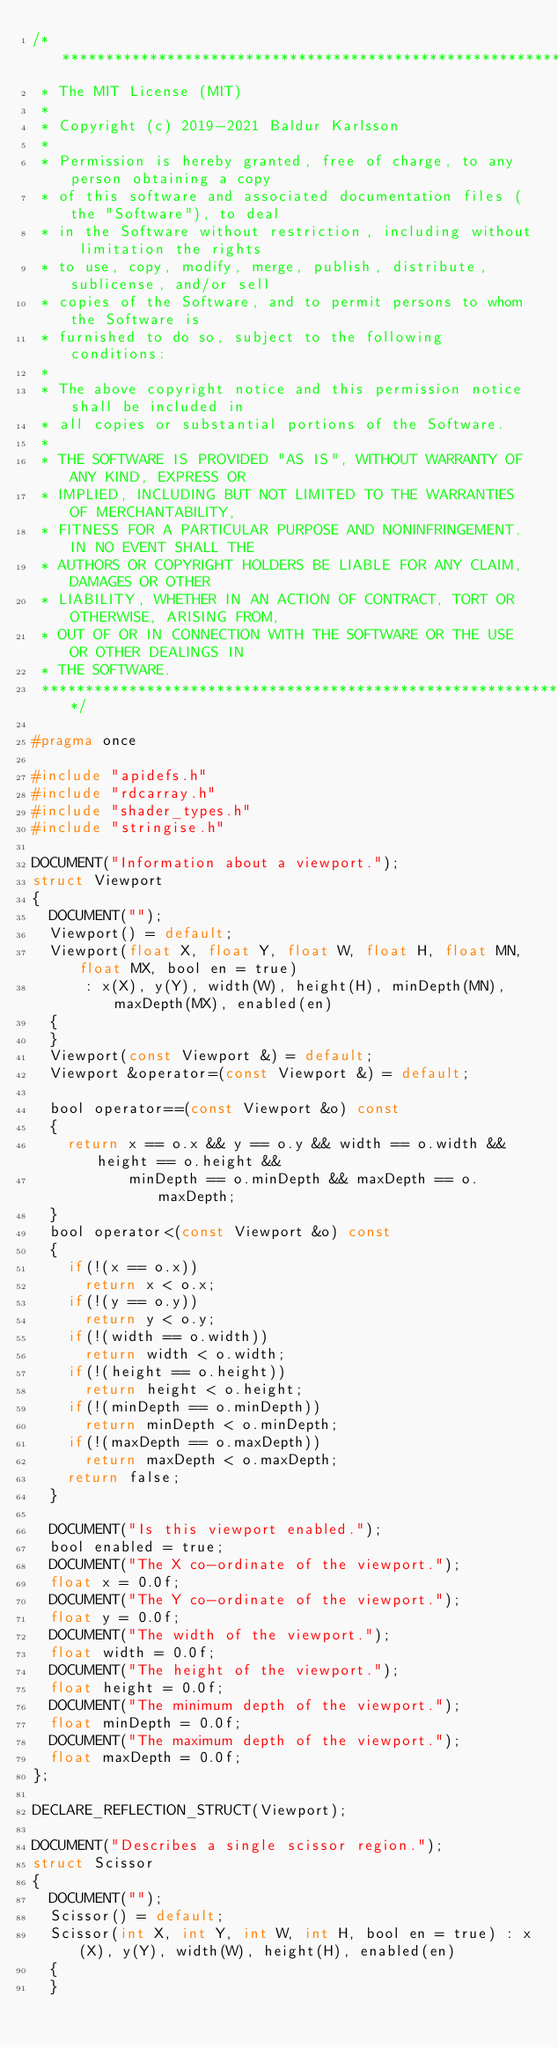Convert code to text. <code><loc_0><loc_0><loc_500><loc_500><_C_>/******************************************************************************
 * The MIT License (MIT)
 *
 * Copyright (c) 2019-2021 Baldur Karlsson
 *
 * Permission is hereby granted, free of charge, to any person obtaining a copy
 * of this software and associated documentation files (the "Software"), to deal
 * in the Software without restriction, including without limitation the rights
 * to use, copy, modify, merge, publish, distribute, sublicense, and/or sell
 * copies of the Software, and to permit persons to whom the Software is
 * furnished to do so, subject to the following conditions:
 *
 * The above copyright notice and this permission notice shall be included in
 * all copies or substantial portions of the Software.
 *
 * THE SOFTWARE IS PROVIDED "AS IS", WITHOUT WARRANTY OF ANY KIND, EXPRESS OR
 * IMPLIED, INCLUDING BUT NOT LIMITED TO THE WARRANTIES OF MERCHANTABILITY,
 * FITNESS FOR A PARTICULAR PURPOSE AND NONINFRINGEMENT. IN NO EVENT SHALL THE
 * AUTHORS OR COPYRIGHT HOLDERS BE LIABLE FOR ANY CLAIM, DAMAGES OR OTHER
 * LIABILITY, WHETHER IN AN ACTION OF CONTRACT, TORT OR OTHERWISE, ARISING FROM,
 * OUT OF OR IN CONNECTION WITH THE SOFTWARE OR THE USE OR OTHER DEALINGS IN
 * THE SOFTWARE.
 ******************************************************************************/

#pragma once

#include "apidefs.h"
#include "rdcarray.h"
#include "shader_types.h"
#include "stringise.h"

DOCUMENT("Information about a viewport.");
struct Viewport
{
  DOCUMENT("");
  Viewport() = default;
  Viewport(float X, float Y, float W, float H, float MN, float MX, bool en = true)
      : x(X), y(Y), width(W), height(H), minDepth(MN), maxDepth(MX), enabled(en)
  {
  }
  Viewport(const Viewport &) = default;
  Viewport &operator=(const Viewport &) = default;

  bool operator==(const Viewport &o) const
  {
    return x == o.x && y == o.y && width == o.width && height == o.height &&
           minDepth == o.minDepth && maxDepth == o.maxDepth;
  }
  bool operator<(const Viewport &o) const
  {
    if(!(x == o.x))
      return x < o.x;
    if(!(y == o.y))
      return y < o.y;
    if(!(width == o.width))
      return width < o.width;
    if(!(height == o.height))
      return height < o.height;
    if(!(minDepth == o.minDepth))
      return minDepth < o.minDepth;
    if(!(maxDepth == o.maxDepth))
      return maxDepth < o.maxDepth;
    return false;
  }

  DOCUMENT("Is this viewport enabled.");
  bool enabled = true;
  DOCUMENT("The X co-ordinate of the viewport.");
  float x = 0.0f;
  DOCUMENT("The Y co-ordinate of the viewport.");
  float y = 0.0f;
  DOCUMENT("The width of the viewport.");
  float width = 0.0f;
  DOCUMENT("The height of the viewport.");
  float height = 0.0f;
  DOCUMENT("The minimum depth of the viewport.");
  float minDepth = 0.0f;
  DOCUMENT("The maximum depth of the viewport.");
  float maxDepth = 0.0f;
};

DECLARE_REFLECTION_STRUCT(Viewport);

DOCUMENT("Describes a single scissor region.");
struct Scissor
{
  DOCUMENT("");
  Scissor() = default;
  Scissor(int X, int Y, int W, int H, bool en = true) : x(X), y(Y), width(W), height(H), enabled(en)
  {
  }</code> 